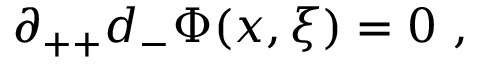<formula> <loc_0><loc_0><loc_500><loc_500>\partial _ { + + } d _ { - } \Phi ( x , \xi ) = 0 \, ,</formula> 